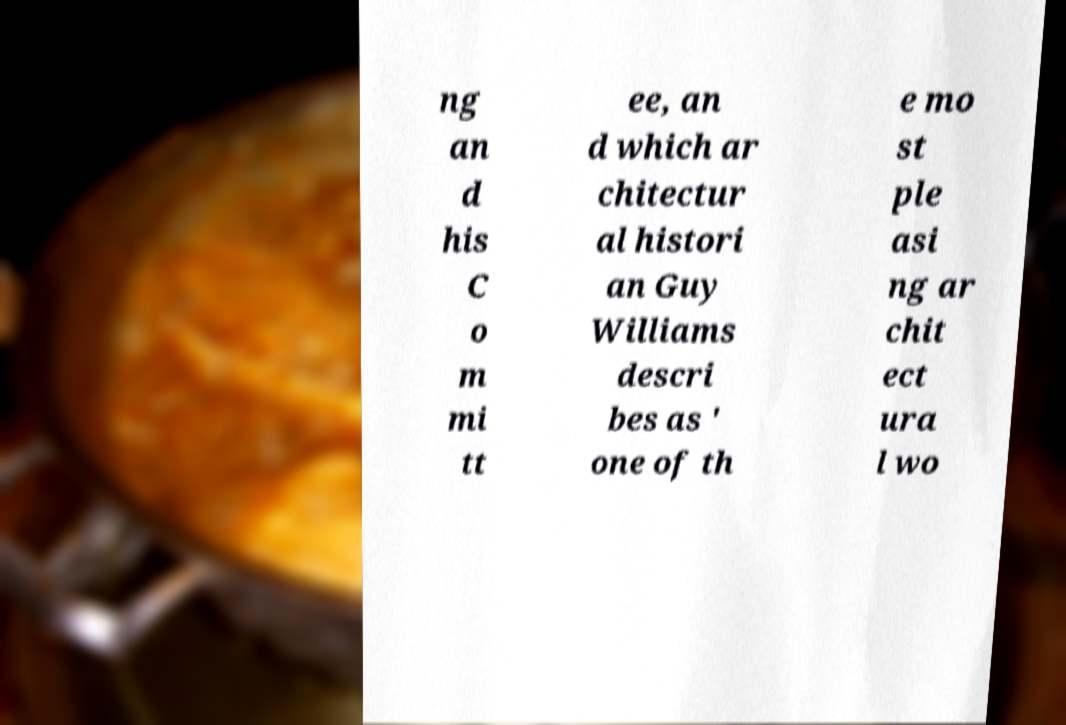There's text embedded in this image that I need extracted. Can you transcribe it verbatim? ng an d his C o m mi tt ee, an d which ar chitectur al histori an Guy Williams descri bes as ' one of th e mo st ple asi ng ar chit ect ura l wo 